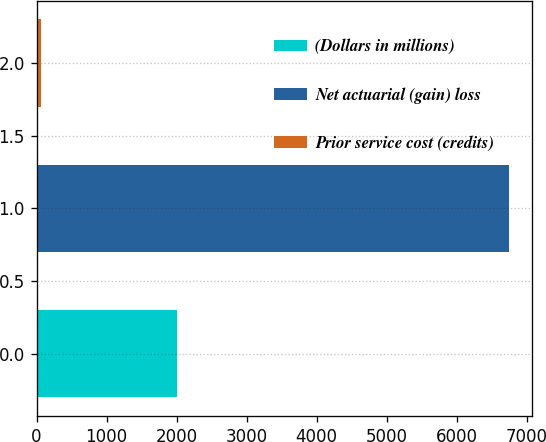Convert chart to OTSL. <chart><loc_0><loc_0><loc_500><loc_500><bar_chart><fcel>(Dollars in millions)<fcel>Net actuarial (gain) loss<fcel>Prior service cost (credits)<nl><fcel>2011<fcel>6743<fcel>67<nl></chart> 